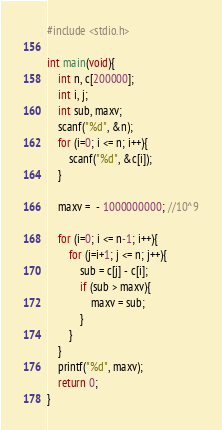Convert code to text. <code><loc_0><loc_0><loc_500><loc_500><_C_>#include <stdio.h>

int main(void){
    int n, c[200000];
    int i, j;
    int sub, maxv;
    scanf("%d", &n);
    for (i=0; i <= n; i++){
        scanf("%d", &c[i]);
    } 
    
    maxv =  - 1000000000; //10^9
    
    for (i=0; i <= n-1; i++){
        for (j=i+1; j <= n; j++){
            sub = c[j] - c[i];
            if (sub > maxv){
                maxv = sub;
            }
        }
    }
    printf("%d", maxv);
    return 0;
}</code> 